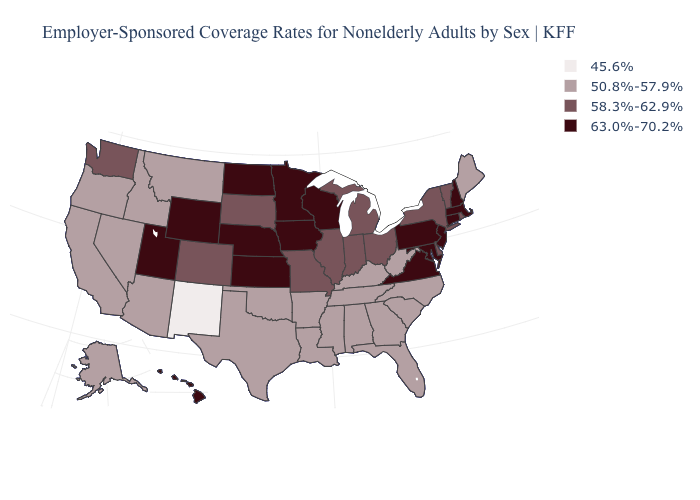What is the value of Wyoming?
Answer briefly. 63.0%-70.2%. How many symbols are there in the legend?
Quick response, please. 4. What is the value of Louisiana?
Be succinct. 50.8%-57.9%. Does Nebraska have the highest value in the MidWest?
Quick response, please. Yes. Name the states that have a value in the range 63.0%-70.2%?
Quick response, please. Connecticut, Hawaii, Iowa, Kansas, Maryland, Massachusetts, Minnesota, Nebraska, New Hampshire, New Jersey, North Dakota, Pennsylvania, Utah, Virginia, Wisconsin, Wyoming. Does Washington have the highest value in the West?
Short answer required. No. Name the states that have a value in the range 58.3%-62.9%?
Keep it brief. Colorado, Delaware, Illinois, Indiana, Michigan, Missouri, New York, Ohio, Rhode Island, South Dakota, Vermont, Washington. Does the map have missing data?
Keep it brief. No. Does Missouri have the highest value in the MidWest?
Short answer required. No. What is the value of Idaho?
Be succinct. 50.8%-57.9%. Name the states that have a value in the range 58.3%-62.9%?
Give a very brief answer. Colorado, Delaware, Illinois, Indiana, Michigan, Missouri, New York, Ohio, Rhode Island, South Dakota, Vermont, Washington. Name the states that have a value in the range 45.6%?
Be succinct. New Mexico. What is the value of New York?
Concise answer only. 58.3%-62.9%. Among the states that border Indiana , does Kentucky have the lowest value?
Keep it brief. Yes. Among the states that border Oregon , which have the highest value?
Keep it brief. Washington. 